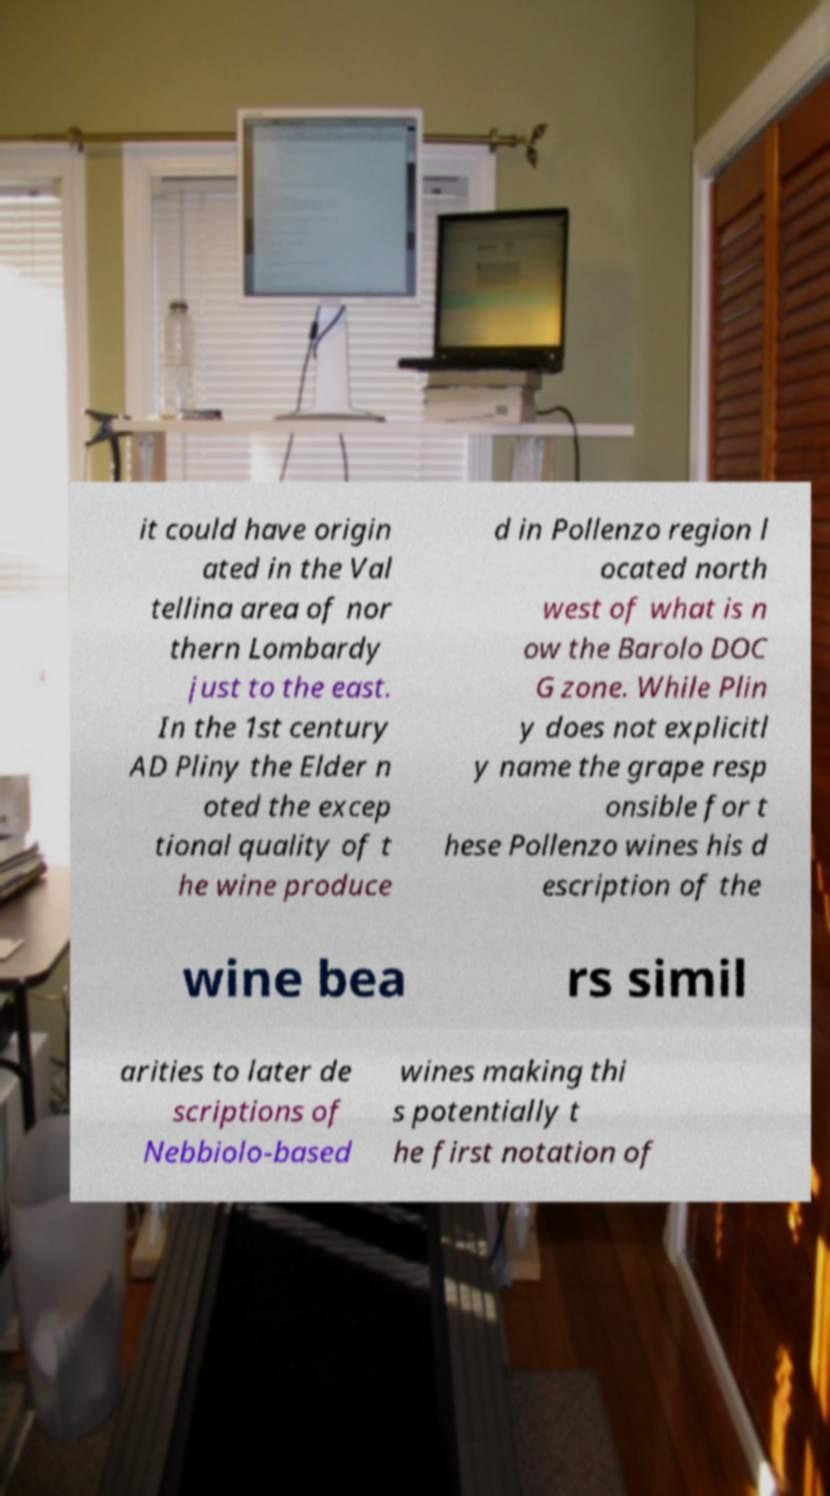Can you accurately transcribe the text from the provided image for me? it could have origin ated in the Val tellina area of nor thern Lombardy just to the east. In the 1st century AD Pliny the Elder n oted the excep tional quality of t he wine produce d in Pollenzo region l ocated north west of what is n ow the Barolo DOC G zone. While Plin y does not explicitl y name the grape resp onsible for t hese Pollenzo wines his d escription of the wine bea rs simil arities to later de scriptions of Nebbiolo-based wines making thi s potentially t he first notation of 